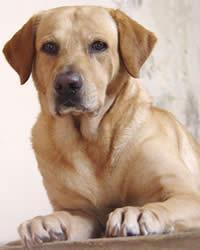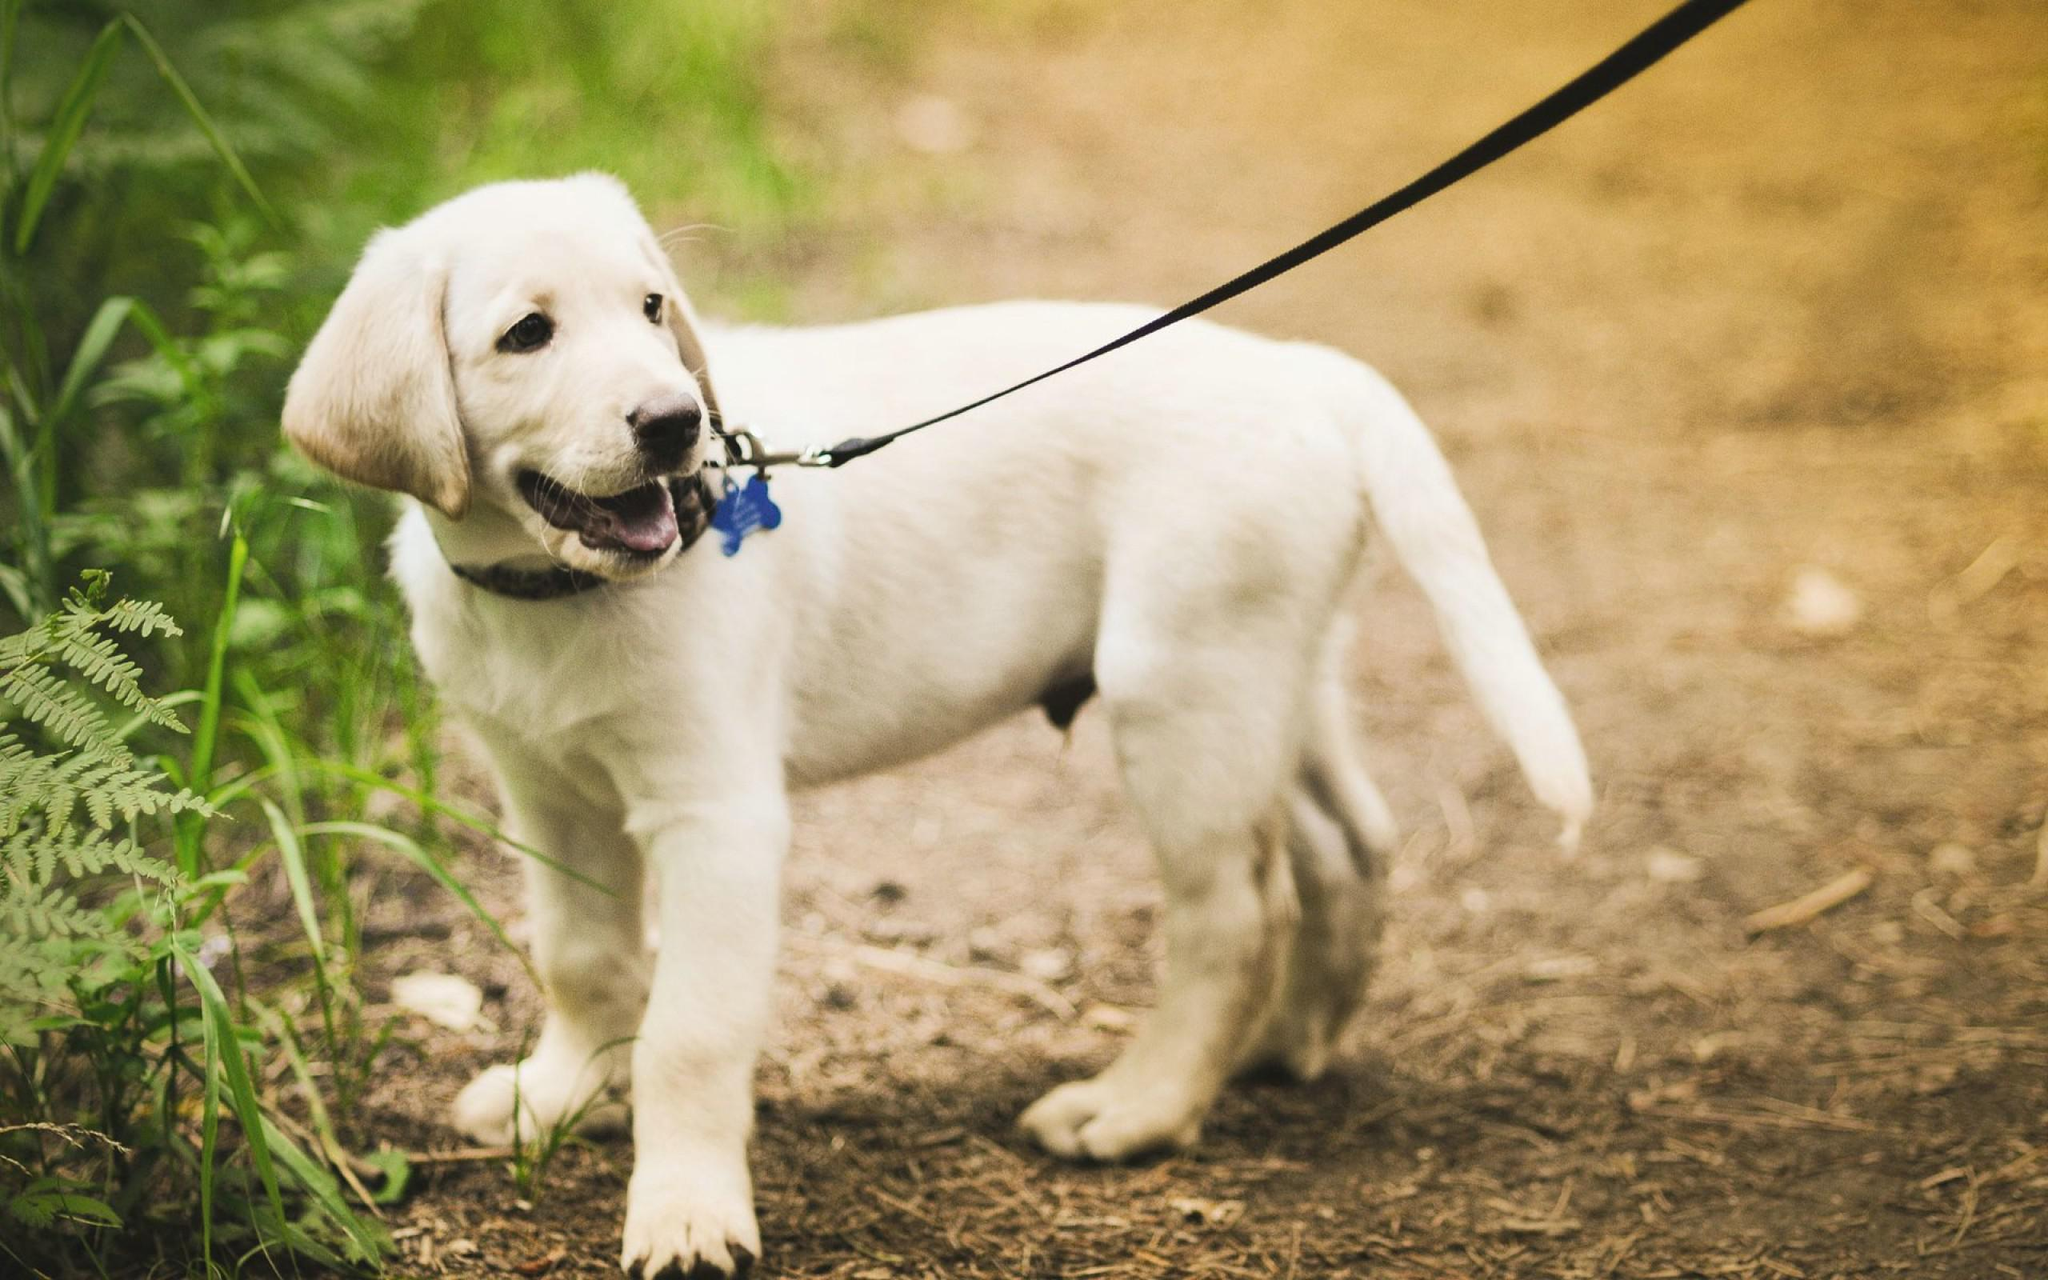The first image is the image on the left, the second image is the image on the right. For the images shown, is this caption "An image shows a standing dog with an open mouth and a collar around its neck." true? Answer yes or no. Yes. The first image is the image on the left, the second image is the image on the right. Examine the images to the left and right. Is the description "One of the dogs is lying down and looking at the camera." accurate? Answer yes or no. Yes. 